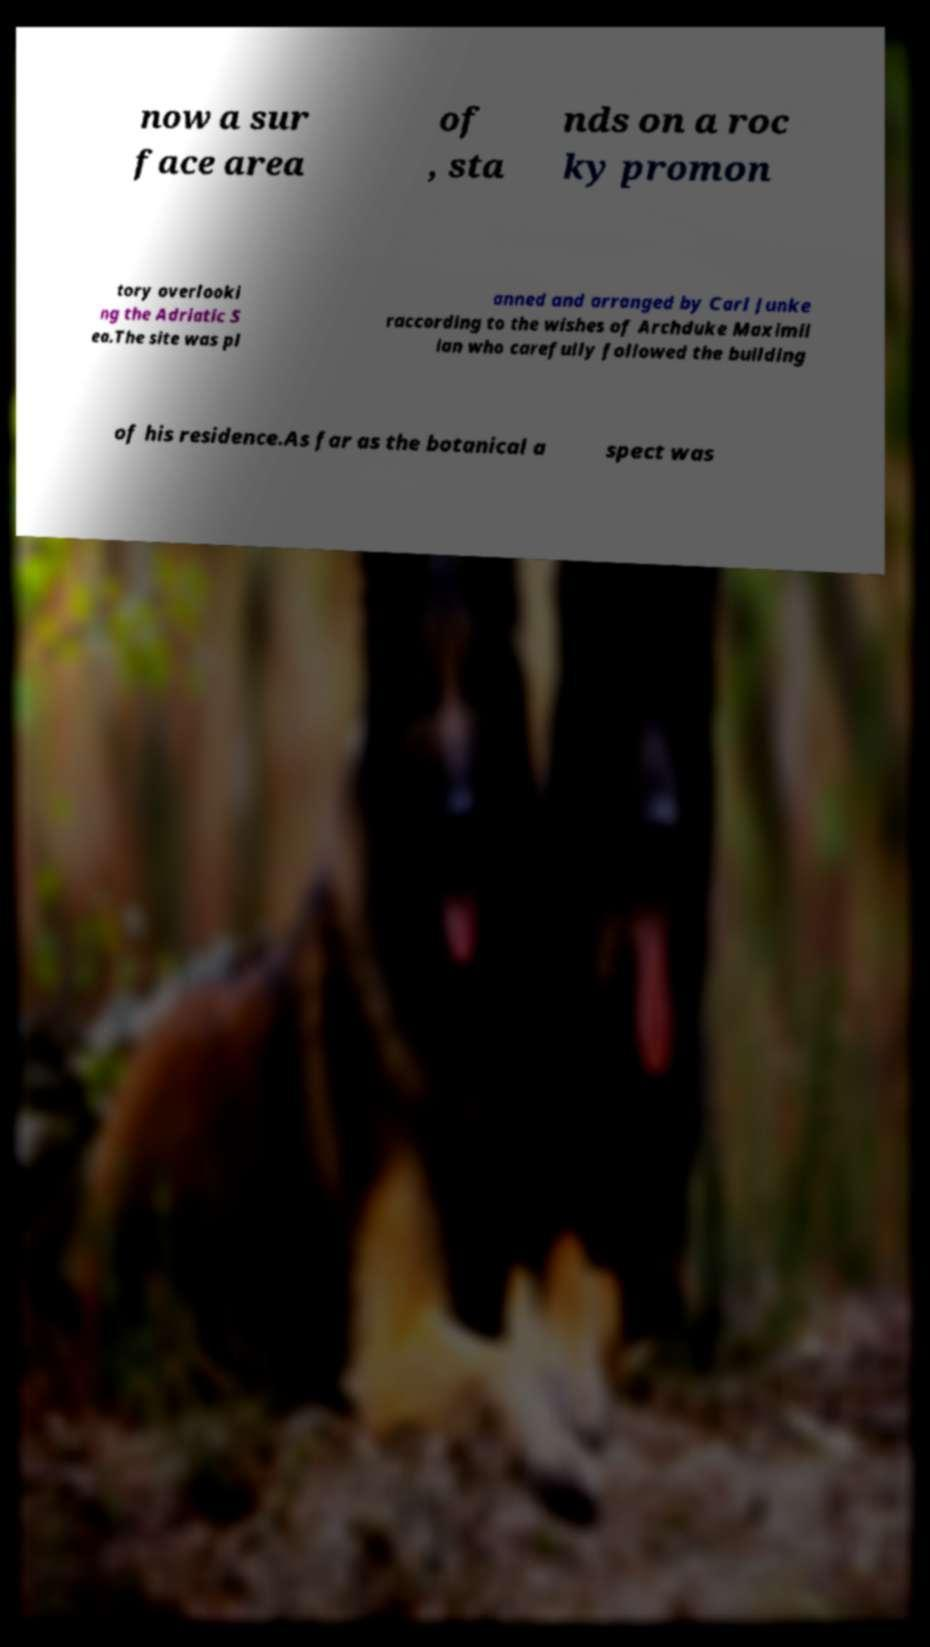What messages or text are displayed in this image? I need them in a readable, typed format. now a sur face area of , sta nds on a roc ky promon tory overlooki ng the Adriatic S ea.The site was pl anned and arranged by Carl Junke raccording to the wishes of Archduke Maximil ian who carefully followed the building of his residence.As far as the botanical a spect was 